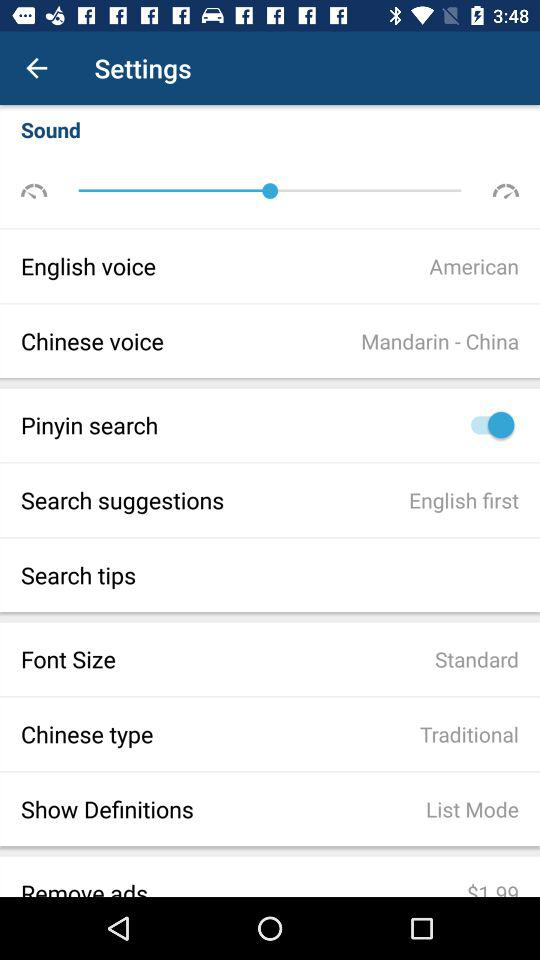What is the font size? The font size is standard. 